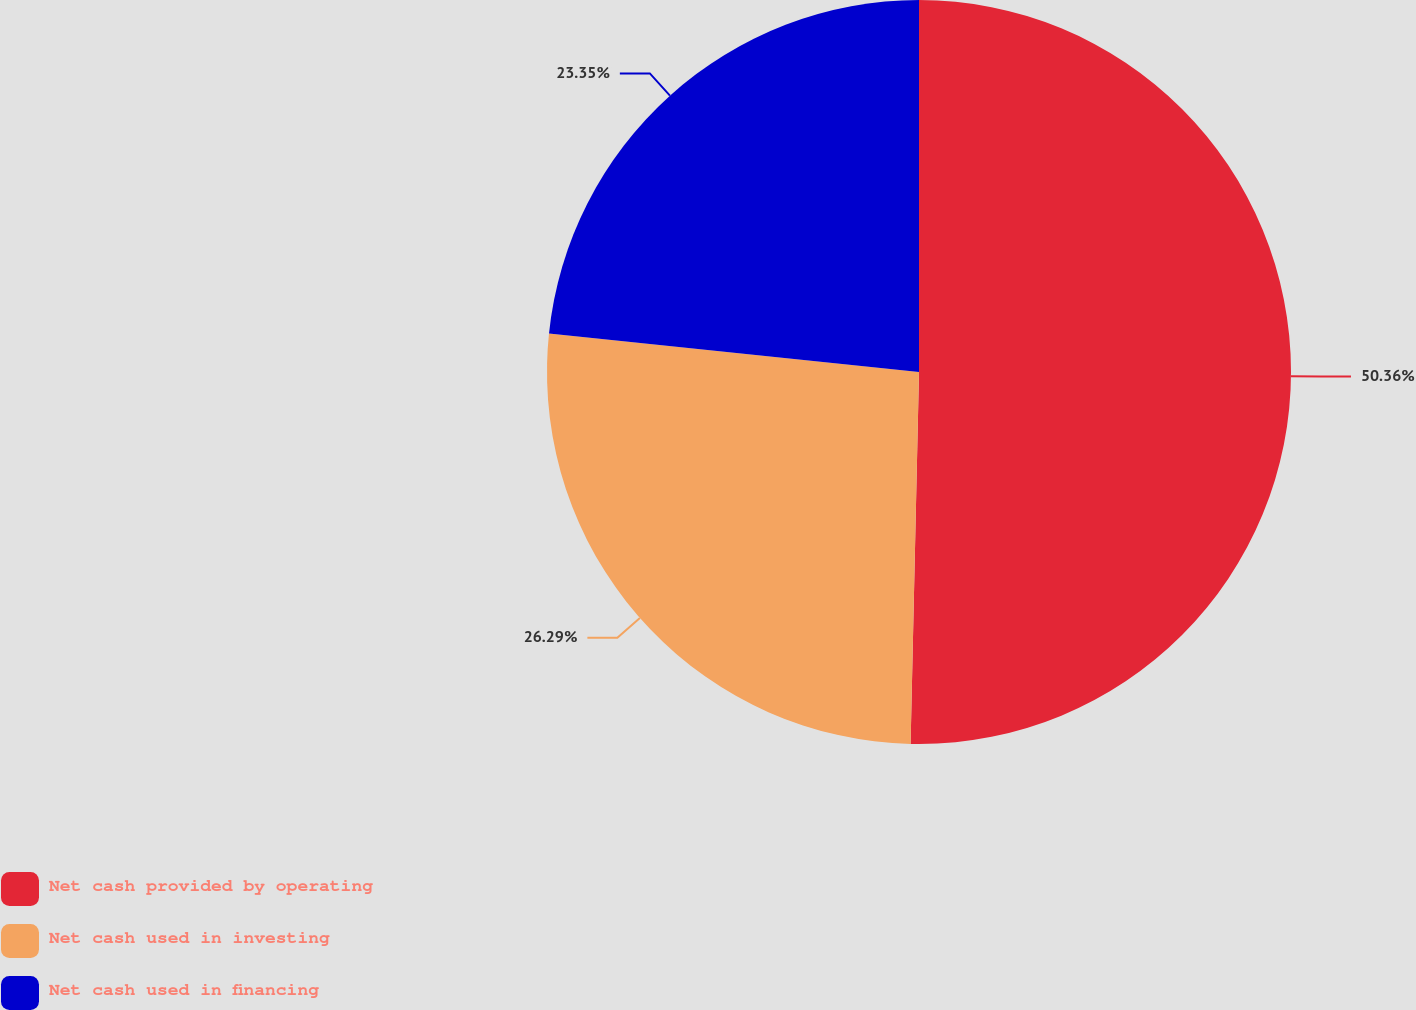<chart> <loc_0><loc_0><loc_500><loc_500><pie_chart><fcel>Net cash provided by operating<fcel>Net cash used in investing<fcel>Net cash used in financing<nl><fcel>50.36%<fcel>26.29%<fcel>23.35%<nl></chart> 